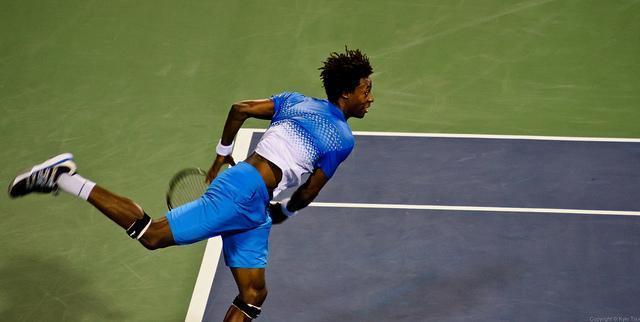How many birds are standing on the boat?
Give a very brief answer. 0. 